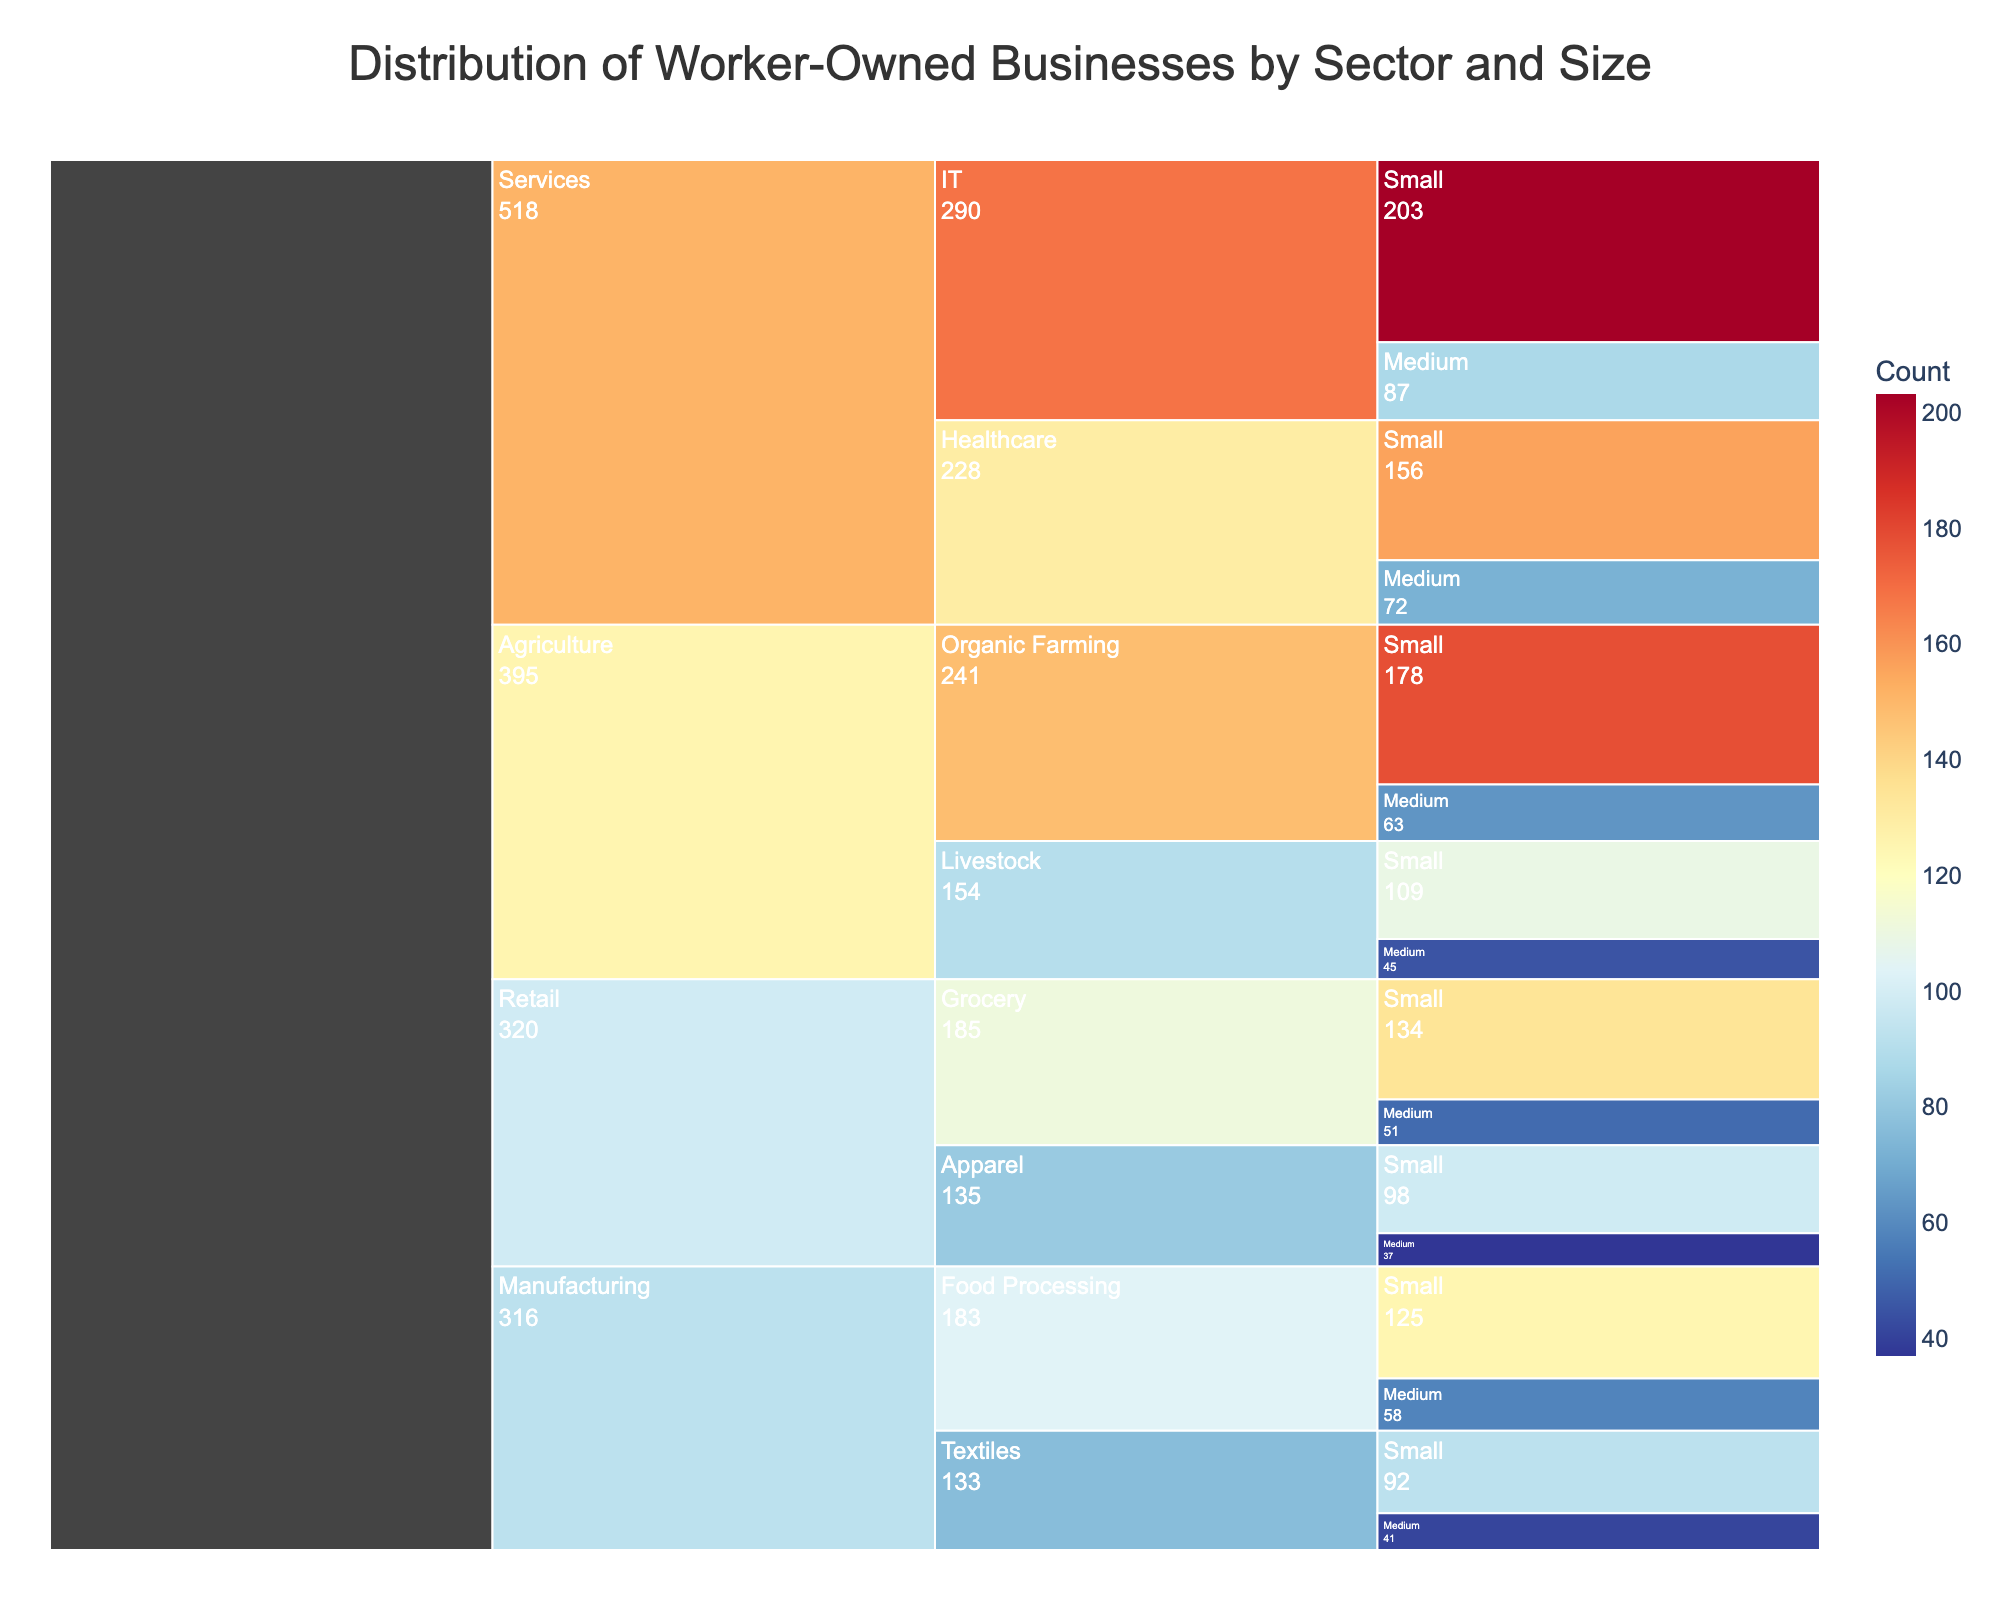What is the title of the chart? The title is displayed prominently at the top of the chart, reading 'Distribution of Worker-Owned Businesses by Sector and Size'.
Answer: Distribution of Worker-Owned Businesses by Sector and Size Which sector has the highest count of small worker-owned businesses? By looking at the icicle chart, the sector with the largest segment tagged 'Small' is the Services sector.
Answer: Services What is the combined count of worker-owned businesses in the Agriculture sector? Add the counts from all sizes and subsectors within Agriculture: 178 (Organic Farming, Small) + 63 (Organic Farming, Medium) + 109 (Livestock, Small) + 45 (Livestock, Medium) = 395.
Answer: 395 Among small-sized businesses, which subsector within Manufacturing has more worker-owned businesses? Compare the counts of small-sized businesses in Food Processing and Textiles: 125 (Food Processing, Small) and 92 (Textiles, Small). Food Processing has more.
Answer: Food Processing How does the number of worker-owned businesses in the Retail sector compare to the Manufacturing sector? Sum the counts for all sizes and subsectors in Retail and Manufacturing then compare: Retail (134 + 51 + 98 + 37 = 320), Manufacturing (125 + 58 + 92 + 41 = 316). Retail has slightly more businesses than Manufacturing.
Answer: Retail has more Which particular subsector and size combination has the lowest count of worker-owned businesses? By examining the smallest segments, Medium-sized Apparel in the Retail sector has the lowest count at 37.
Answer: Medium-sized Apparel in Retail If the count for medium-sized IT businesses in the Services sector is combined with the count for small IT businesses, what would the total be? Sum the counts for medium-sized IT (87) and small-sized IT (203): 87 + 203 = 290.
Answer: 290 In which sector and size is there a significant drop in count between small and medium sizes? Compare the counts between sizes within each sector, noticing significant drops. In Organic Farming within the Agriculture sector, the count drops from 178 (small) to 63 (medium).
Answer: Organic Farming in Agriculture Calculate the average count of medium-sized businesses across all sectors and subsectors. Sum the counts of all medium-sized segments and divide by the number of segments: (58 + 41 + 87 + 72 + 63 + 45 + 51 + 37) / 8 = 454 / 8 = 56.75.
Answer: 56.75 